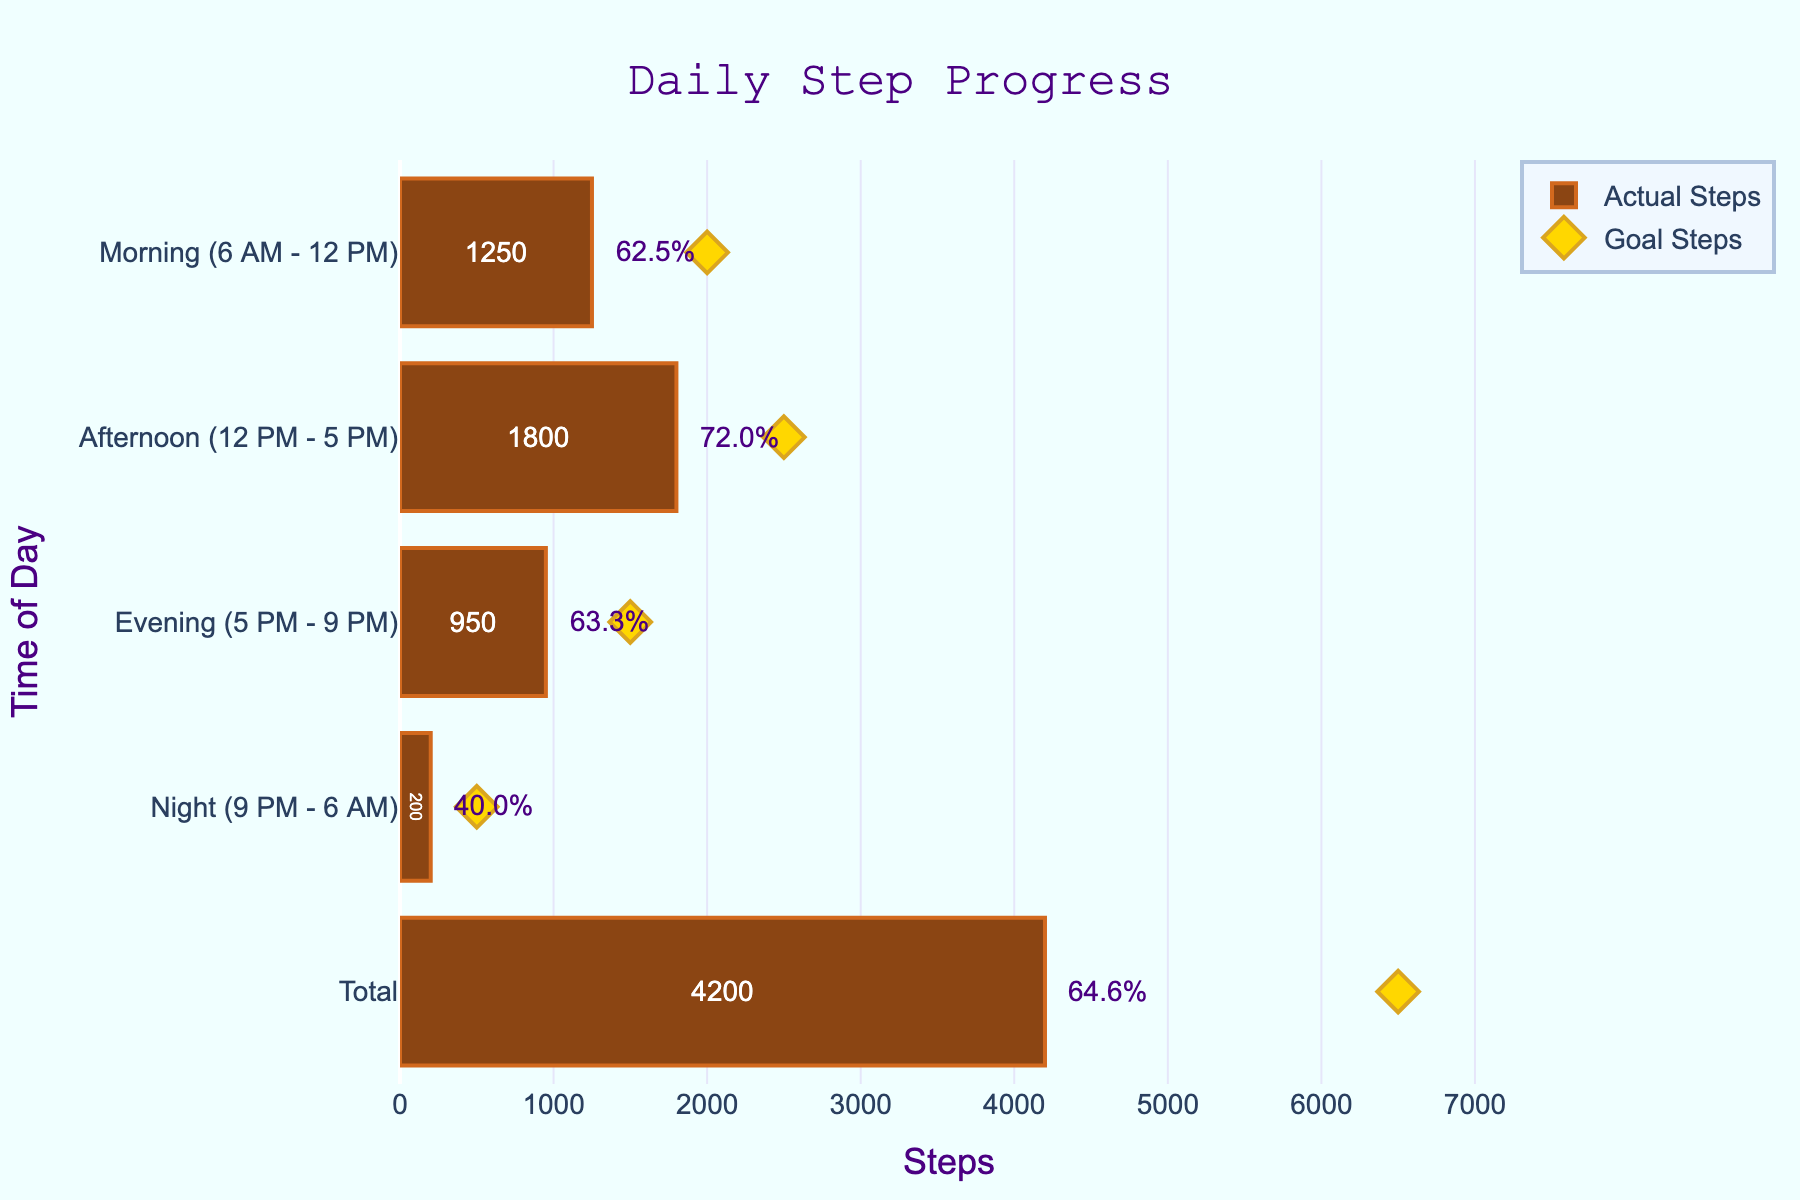what is the title of the chart? The title of the chart is provided at the top center in a larger font size and different color compared to other text elements in the figure.
Answer: Daily Step Progress what period had the highest number of actual steps? Look at the length of the bars representing the actual steps for each time period. The period with the longest bar indicates the highest number of actual steps.
Answer: Afternoon (12 PM - 5 PM) what is the percentage of the daily step goal achieved in the morning? The percentage is displayed next to the bar representing morning actual steps.
Answer: 62.5% how many total steps were actually taken throughout the day? Add the actual steps for each time period: Morning (1250) + Afternoon (1800) + Evening (950) + Night (200)
Answer: 4200 how close was the evening actual step count to its goal? Compare the evening actual step count (950) to its goal (1500): 1500 - 950 = 550 steps short of the goal.
Answer: 550 which time period had the smallest discrepancy between actual and goal steps? Calculate the difference between actual and goal steps for each period. The period with the smallest difference is the answer. Morning (2000-1250=750), Afternoon (2500-1800=700), Evening (1500-950=550), Night (500-200=300).
Answer: Night (9 PM - 6 AM) had the smallest discrepancy of 300 steps In which time period was the step goal least met? Find the percentage for each time period and identify the smallest value, which corresponds to the least met goal. The percentages are indicated next to the bars.
Answer: Night (9 PM - 6 AM) what is the difference between the total actual steps and the total goal steps for the entire day? Subtract the total actual steps (4200) from the total goal steps (6500): 6500 - 4200
Answer: 2300 which two periods combined account for the majority of actual steps taken? Compare combinations of periods to determine which pair has the highest combined actual steps: 
Morning + Afternoon: 1250 + 1800 = 3050 
Morning + Evening: 1250 + 950 = 2200 
Morning + Night: 1250 + 200 = 1450 
Afternoon + Evening: 1800 + 950 = 2750 
Afternoon + Night: 1800 + 200 = 2000 
Evening + Night: 950 + 200 = 1150. The combination of Morning and Afternoon has the highest total, 3050.
Answer: Morning and Afternoon why are there markers on the chart? The markers (diamond symbols) indicate the goal steps for each time period, allowing for a visual comparison with the actual steps achieved.
Answer: They signify the goal steps 